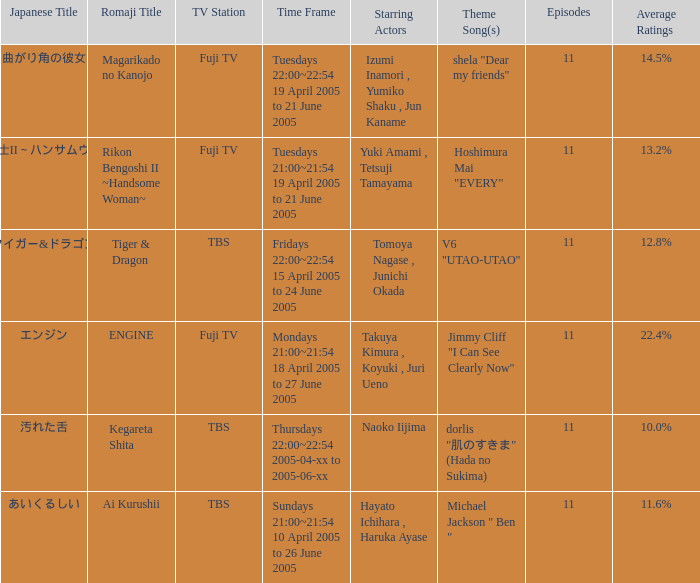What is maximum number of episodes for a show? 11.0. 